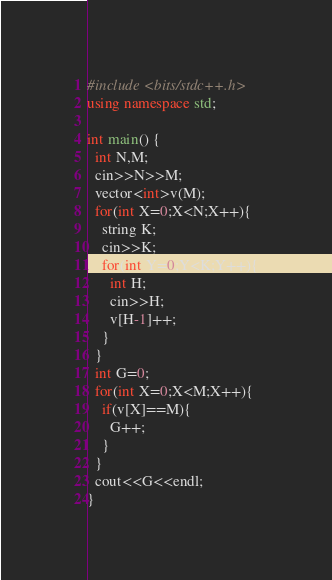Convert code to text. <code><loc_0><loc_0><loc_500><loc_500><_C++_>#include <bits/stdc++.h>
using namespace std;
 
int main() {
  int N,M;
  cin>>N>>M;
  vector<int>v(M);
  for(int X=0;X<N;X++){
    string K;
    cin>>K;
    for(int Y=0;Y<K;Y++){
      int H;
      cin>>H;
      v[H-1]++;
    }
  }
  int G=0;
  for(int X=0;X<M;X++){
    if(v[X]==M){
      G++;
    }
  }
  cout<<G<<endl;
}</code> 